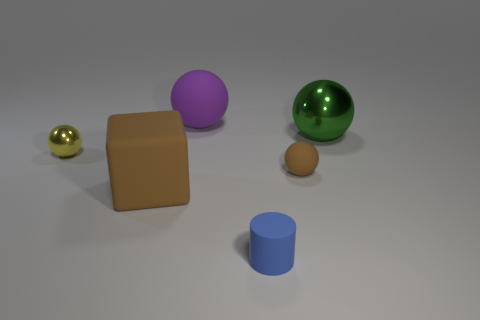Subtract all large purple spheres. How many spheres are left? 3 Add 2 big yellow matte cylinders. How many objects exist? 8 Subtract all spheres. How many objects are left? 2 Subtract all green balls. How many balls are left? 3 Subtract 0 yellow cylinders. How many objects are left? 6 Subtract 3 balls. How many balls are left? 1 Subtract all red cylinders. Subtract all blue blocks. How many cylinders are left? 1 Subtract all brown cylinders. How many red balls are left? 0 Subtract all large blue objects. Subtract all shiny balls. How many objects are left? 4 Add 4 tiny brown matte objects. How many tiny brown matte objects are left? 5 